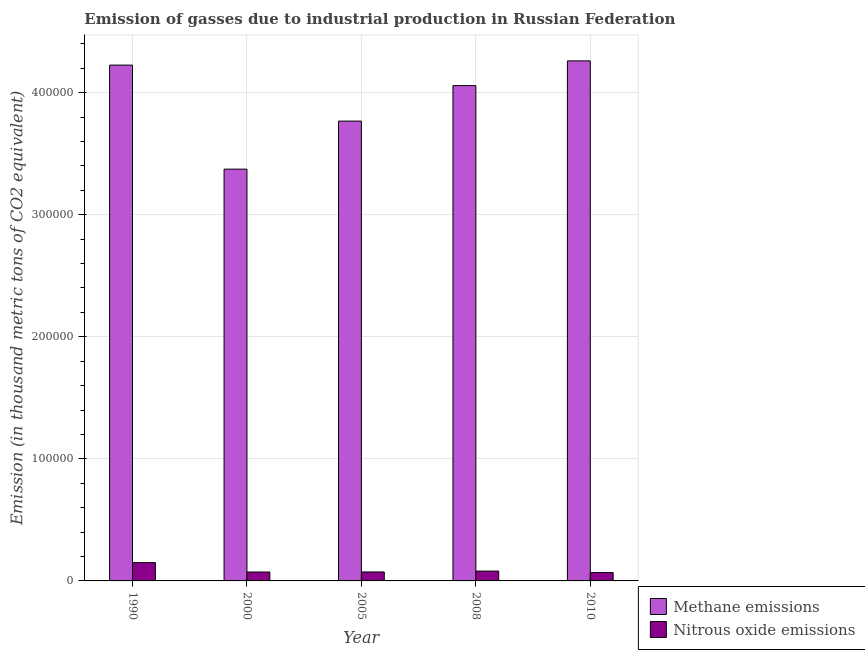How many different coloured bars are there?
Your response must be concise. 2. How many groups of bars are there?
Your answer should be compact. 5. What is the amount of methane emissions in 1990?
Provide a short and direct response. 4.23e+05. Across all years, what is the maximum amount of nitrous oxide emissions?
Ensure brevity in your answer.  1.50e+04. Across all years, what is the minimum amount of methane emissions?
Offer a very short reply. 3.37e+05. In which year was the amount of methane emissions maximum?
Keep it short and to the point. 2010. What is the total amount of methane emissions in the graph?
Your response must be concise. 1.97e+06. What is the difference between the amount of methane emissions in 2005 and that in 2010?
Your answer should be compact. -4.93e+04. What is the difference between the amount of nitrous oxide emissions in 2005 and the amount of methane emissions in 2010?
Your response must be concise. 531.3. What is the average amount of nitrous oxide emissions per year?
Offer a terse response. 8900.66. What is the ratio of the amount of nitrous oxide emissions in 2008 to that in 2010?
Offer a very short reply. 1.18. What is the difference between the highest and the second highest amount of methane emissions?
Make the answer very short. 3466. What is the difference between the highest and the lowest amount of nitrous oxide emissions?
Your answer should be very brief. 8182.5. What does the 2nd bar from the left in 2010 represents?
Keep it short and to the point. Nitrous oxide emissions. What does the 2nd bar from the right in 2005 represents?
Your response must be concise. Methane emissions. How many bars are there?
Offer a very short reply. 10. Are all the bars in the graph horizontal?
Provide a succinct answer. No. How many years are there in the graph?
Ensure brevity in your answer.  5. What is the difference between two consecutive major ticks on the Y-axis?
Provide a succinct answer. 1.00e+05. Are the values on the major ticks of Y-axis written in scientific E-notation?
Provide a succinct answer. No. Does the graph contain grids?
Make the answer very short. Yes. Where does the legend appear in the graph?
Make the answer very short. Bottom right. How many legend labels are there?
Make the answer very short. 2. What is the title of the graph?
Your answer should be very brief. Emission of gasses due to industrial production in Russian Federation. What is the label or title of the Y-axis?
Your response must be concise. Emission (in thousand metric tons of CO2 equivalent). What is the Emission (in thousand metric tons of CO2 equivalent) in Methane emissions in 1990?
Provide a short and direct response. 4.23e+05. What is the Emission (in thousand metric tons of CO2 equivalent) in Nitrous oxide emissions in 1990?
Your answer should be compact. 1.50e+04. What is the Emission (in thousand metric tons of CO2 equivalent) of Methane emissions in 2000?
Your answer should be compact. 3.37e+05. What is the Emission (in thousand metric tons of CO2 equivalent) of Nitrous oxide emissions in 2000?
Offer a very short reply. 7288.4. What is the Emission (in thousand metric tons of CO2 equivalent) in Methane emissions in 2005?
Provide a short and direct response. 3.77e+05. What is the Emission (in thousand metric tons of CO2 equivalent) in Nitrous oxide emissions in 2005?
Your answer should be very brief. 7344.1. What is the Emission (in thousand metric tons of CO2 equivalent) in Methane emissions in 2008?
Offer a very short reply. 4.06e+05. What is the Emission (in thousand metric tons of CO2 equivalent) of Nitrous oxide emissions in 2008?
Offer a very short reply. 8062.7. What is the Emission (in thousand metric tons of CO2 equivalent) in Methane emissions in 2010?
Your answer should be compact. 4.26e+05. What is the Emission (in thousand metric tons of CO2 equivalent) in Nitrous oxide emissions in 2010?
Your answer should be compact. 6812.8. Across all years, what is the maximum Emission (in thousand metric tons of CO2 equivalent) of Methane emissions?
Your answer should be very brief. 4.26e+05. Across all years, what is the maximum Emission (in thousand metric tons of CO2 equivalent) in Nitrous oxide emissions?
Keep it short and to the point. 1.50e+04. Across all years, what is the minimum Emission (in thousand metric tons of CO2 equivalent) in Methane emissions?
Your answer should be compact. 3.37e+05. Across all years, what is the minimum Emission (in thousand metric tons of CO2 equivalent) of Nitrous oxide emissions?
Provide a succinct answer. 6812.8. What is the total Emission (in thousand metric tons of CO2 equivalent) in Methane emissions in the graph?
Your answer should be compact. 1.97e+06. What is the total Emission (in thousand metric tons of CO2 equivalent) in Nitrous oxide emissions in the graph?
Keep it short and to the point. 4.45e+04. What is the difference between the Emission (in thousand metric tons of CO2 equivalent) of Methane emissions in 1990 and that in 2000?
Give a very brief answer. 8.52e+04. What is the difference between the Emission (in thousand metric tons of CO2 equivalent) in Nitrous oxide emissions in 1990 and that in 2000?
Provide a succinct answer. 7706.9. What is the difference between the Emission (in thousand metric tons of CO2 equivalent) of Methane emissions in 1990 and that in 2005?
Provide a short and direct response. 4.58e+04. What is the difference between the Emission (in thousand metric tons of CO2 equivalent) of Nitrous oxide emissions in 1990 and that in 2005?
Offer a terse response. 7651.2. What is the difference between the Emission (in thousand metric tons of CO2 equivalent) of Methane emissions in 1990 and that in 2008?
Your answer should be compact. 1.68e+04. What is the difference between the Emission (in thousand metric tons of CO2 equivalent) in Nitrous oxide emissions in 1990 and that in 2008?
Your response must be concise. 6932.6. What is the difference between the Emission (in thousand metric tons of CO2 equivalent) in Methane emissions in 1990 and that in 2010?
Your response must be concise. -3466. What is the difference between the Emission (in thousand metric tons of CO2 equivalent) of Nitrous oxide emissions in 1990 and that in 2010?
Provide a short and direct response. 8182.5. What is the difference between the Emission (in thousand metric tons of CO2 equivalent) of Methane emissions in 2000 and that in 2005?
Provide a short and direct response. -3.94e+04. What is the difference between the Emission (in thousand metric tons of CO2 equivalent) in Nitrous oxide emissions in 2000 and that in 2005?
Your response must be concise. -55.7. What is the difference between the Emission (in thousand metric tons of CO2 equivalent) in Methane emissions in 2000 and that in 2008?
Ensure brevity in your answer.  -6.84e+04. What is the difference between the Emission (in thousand metric tons of CO2 equivalent) in Nitrous oxide emissions in 2000 and that in 2008?
Ensure brevity in your answer.  -774.3. What is the difference between the Emission (in thousand metric tons of CO2 equivalent) in Methane emissions in 2000 and that in 2010?
Make the answer very short. -8.87e+04. What is the difference between the Emission (in thousand metric tons of CO2 equivalent) in Nitrous oxide emissions in 2000 and that in 2010?
Provide a succinct answer. 475.6. What is the difference between the Emission (in thousand metric tons of CO2 equivalent) of Methane emissions in 2005 and that in 2008?
Provide a short and direct response. -2.90e+04. What is the difference between the Emission (in thousand metric tons of CO2 equivalent) of Nitrous oxide emissions in 2005 and that in 2008?
Make the answer very short. -718.6. What is the difference between the Emission (in thousand metric tons of CO2 equivalent) in Methane emissions in 2005 and that in 2010?
Provide a succinct answer. -4.93e+04. What is the difference between the Emission (in thousand metric tons of CO2 equivalent) in Nitrous oxide emissions in 2005 and that in 2010?
Provide a short and direct response. 531.3. What is the difference between the Emission (in thousand metric tons of CO2 equivalent) in Methane emissions in 2008 and that in 2010?
Offer a very short reply. -2.03e+04. What is the difference between the Emission (in thousand metric tons of CO2 equivalent) of Nitrous oxide emissions in 2008 and that in 2010?
Make the answer very short. 1249.9. What is the difference between the Emission (in thousand metric tons of CO2 equivalent) of Methane emissions in 1990 and the Emission (in thousand metric tons of CO2 equivalent) of Nitrous oxide emissions in 2000?
Provide a short and direct response. 4.15e+05. What is the difference between the Emission (in thousand metric tons of CO2 equivalent) in Methane emissions in 1990 and the Emission (in thousand metric tons of CO2 equivalent) in Nitrous oxide emissions in 2005?
Offer a terse response. 4.15e+05. What is the difference between the Emission (in thousand metric tons of CO2 equivalent) of Methane emissions in 1990 and the Emission (in thousand metric tons of CO2 equivalent) of Nitrous oxide emissions in 2008?
Make the answer very short. 4.14e+05. What is the difference between the Emission (in thousand metric tons of CO2 equivalent) of Methane emissions in 1990 and the Emission (in thousand metric tons of CO2 equivalent) of Nitrous oxide emissions in 2010?
Ensure brevity in your answer.  4.16e+05. What is the difference between the Emission (in thousand metric tons of CO2 equivalent) of Methane emissions in 2000 and the Emission (in thousand metric tons of CO2 equivalent) of Nitrous oxide emissions in 2005?
Your response must be concise. 3.30e+05. What is the difference between the Emission (in thousand metric tons of CO2 equivalent) in Methane emissions in 2000 and the Emission (in thousand metric tons of CO2 equivalent) in Nitrous oxide emissions in 2008?
Your answer should be very brief. 3.29e+05. What is the difference between the Emission (in thousand metric tons of CO2 equivalent) of Methane emissions in 2000 and the Emission (in thousand metric tons of CO2 equivalent) of Nitrous oxide emissions in 2010?
Ensure brevity in your answer.  3.30e+05. What is the difference between the Emission (in thousand metric tons of CO2 equivalent) in Methane emissions in 2005 and the Emission (in thousand metric tons of CO2 equivalent) in Nitrous oxide emissions in 2008?
Offer a terse response. 3.69e+05. What is the difference between the Emission (in thousand metric tons of CO2 equivalent) in Methane emissions in 2005 and the Emission (in thousand metric tons of CO2 equivalent) in Nitrous oxide emissions in 2010?
Offer a very short reply. 3.70e+05. What is the difference between the Emission (in thousand metric tons of CO2 equivalent) of Methane emissions in 2008 and the Emission (in thousand metric tons of CO2 equivalent) of Nitrous oxide emissions in 2010?
Provide a short and direct response. 3.99e+05. What is the average Emission (in thousand metric tons of CO2 equivalent) of Methane emissions per year?
Your answer should be compact. 3.94e+05. What is the average Emission (in thousand metric tons of CO2 equivalent) in Nitrous oxide emissions per year?
Provide a succinct answer. 8900.66. In the year 1990, what is the difference between the Emission (in thousand metric tons of CO2 equivalent) in Methane emissions and Emission (in thousand metric tons of CO2 equivalent) in Nitrous oxide emissions?
Your response must be concise. 4.08e+05. In the year 2000, what is the difference between the Emission (in thousand metric tons of CO2 equivalent) of Methane emissions and Emission (in thousand metric tons of CO2 equivalent) of Nitrous oxide emissions?
Keep it short and to the point. 3.30e+05. In the year 2005, what is the difference between the Emission (in thousand metric tons of CO2 equivalent) in Methane emissions and Emission (in thousand metric tons of CO2 equivalent) in Nitrous oxide emissions?
Your answer should be very brief. 3.69e+05. In the year 2008, what is the difference between the Emission (in thousand metric tons of CO2 equivalent) in Methane emissions and Emission (in thousand metric tons of CO2 equivalent) in Nitrous oxide emissions?
Offer a terse response. 3.98e+05. In the year 2010, what is the difference between the Emission (in thousand metric tons of CO2 equivalent) of Methane emissions and Emission (in thousand metric tons of CO2 equivalent) of Nitrous oxide emissions?
Make the answer very short. 4.19e+05. What is the ratio of the Emission (in thousand metric tons of CO2 equivalent) in Methane emissions in 1990 to that in 2000?
Your response must be concise. 1.25. What is the ratio of the Emission (in thousand metric tons of CO2 equivalent) of Nitrous oxide emissions in 1990 to that in 2000?
Keep it short and to the point. 2.06. What is the ratio of the Emission (in thousand metric tons of CO2 equivalent) of Methane emissions in 1990 to that in 2005?
Your answer should be very brief. 1.12. What is the ratio of the Emission (in thousand metric tons of CO2 equivalent) in Nitrous oxide emissions in 1990 to that in 2005?
Offer a terse response. 2.04. What is the ratio of the Emission (in thousand metric tons of CO2 equivalent) of Methane emissions in 1990 to that in 2008?
Give a very brief answer. 1.04. What is the ratio of the Emission (in thousand metric tons of CO2 equivalent) in Nitrous oxide emissions in 1990 to that in 2008?
Make the answer very short. 1.86. What is the ratio of the Emission (in thousand metric tons of CO2 equivalent) in Nitrous oxide emissions in 1990 to that in 2010?
Keep it short and to the point. 2.2. What is the ratio of the Emission (in thousand metric tons of CO2 equivalent) in Methane emissions in 2000 to that in 2005?
Your answer should be compact. 0.9. What is the ratio of the Emission (in thousand metric tons of CO2 equivalent) of Methane emissions in 2000 to that in 2008?
Your answer should be compact. 0.83. What is the ratio of the Emission (in thousand metric tons of CO2 equivalent) in Nitrous oxide emissions in 2000 to that in 2008?
Keep it short and to the point. 0.9. What is the ratio of the Emission (in thousand metric tons of CO2 equivalent) of Methane emissions in 2000 to that in 2010?
Give a very brief answer. 0.79. What is the ratio of the Emission (in thousand metric tons of CO2 equivalent) in Nitrous oxide emissions in 2000 to that in 2010?
Your answer should be compact. 1.07. What is the ratio of the Emission (in thousand metric tons of CO2 equivalent) of Methane emissions in 2005 to that in 2008?
Give a very brief answer. 0.93. What is the ratio of the Emission (in thousand metric tons of CO2 equivalent) of Nitrous oxide emissions in 2005 to that in 2008?
Your response must be concise. 0.91. What is the ratio of the Emission (in thousand metric tons of CO2 equivalent) in Methane emissions in 2005 to that in 2010?
Offer a terse response. 0.88. What is the ratio of the Emission (in thousand metric tons of CO2 equivalent) of Nitrous oxide emissions in 2005 to that in 2010?
Your response must be concise. 1.08. What is the ratio of the Emission (in thousand metric tons of CO2 equivalent) in Methane emissions in 2008 to that in 2010?
Your answer should be very brief. 0.95. What is the ratio of the Emission (in thousand metric tons of CO2 equivalent) of Nitrous oxide emissions in 2008 to that in 2010?
Provide a succinct answer. 1.18. What is the difference between the highest and the second highest Emission (in thousand metric tons of CO2 equivalent) in Methane emissions?
Your response must be concise. 3466. What is the difference between the highest and the second highest Emission (in thousand metric tons of CO2 equivalent) in Nitrous oxide emissions?
Your answer should be very brief. 6932.6. What is the difference between the highest and the lowest Emission (in thousand metric tons of CO2 equivalent) in Methane emissions?
Give a very brief answer. 8.87e+04. What is the difference between the highest and the lowest Emission (in thousand metric tons of CO2 equivalent) of Nitrous oxide emissions?
Your answer should be compact. 8182.5. 